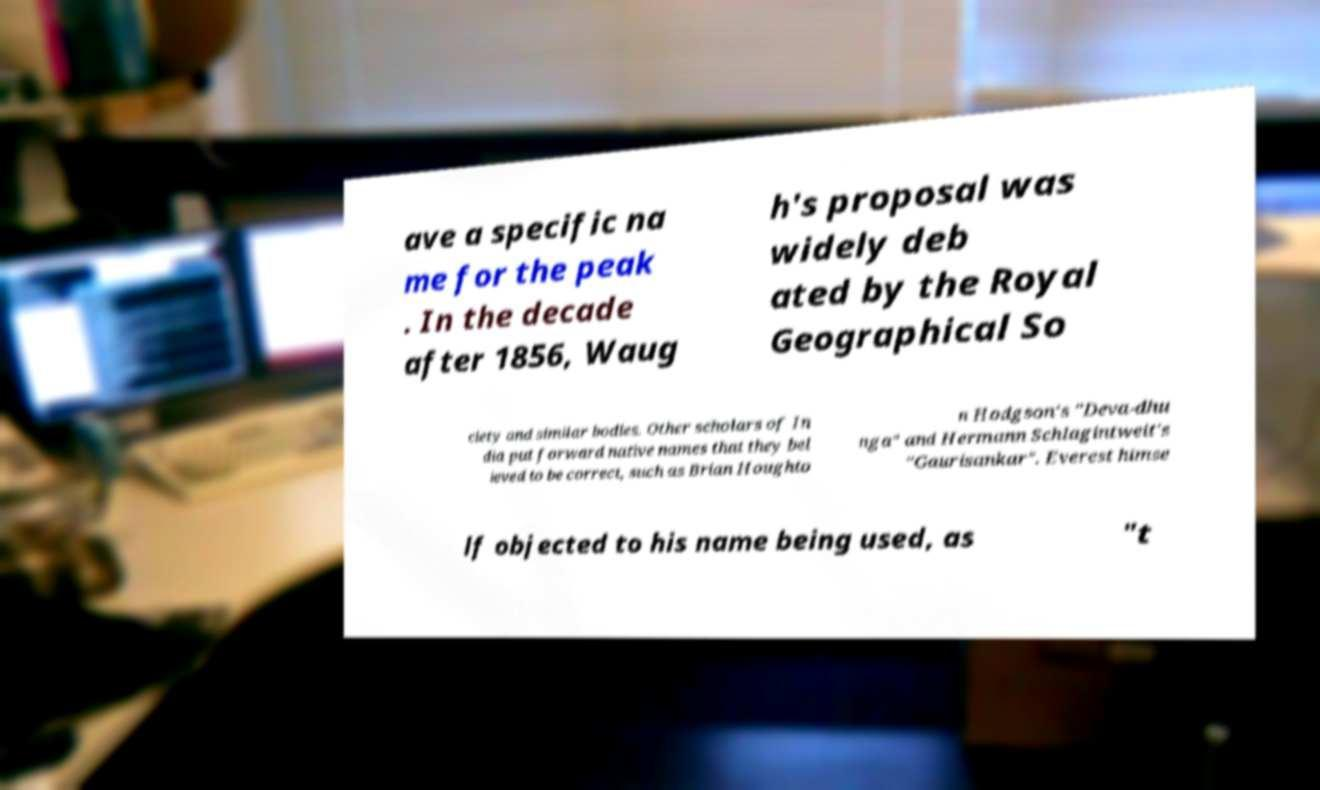Can you read and provide the text displayed in the image?This photo seems to have some interesting text. Can you extract and type it out for me? ave a specific na me for the peak . In the decade after 1856, Waug h's proposal was widely deb ated by the Royal Geographical So ciety and similar bodies. Other scholars of In dia put forward native names that they bel ieved to be correct, such as Brian Houghto n Hodgson's "Deva-dhu nga" and Hermann Schlagintweit's "Gaurisankar". Everest himse lf objected to his name being used, as "t 